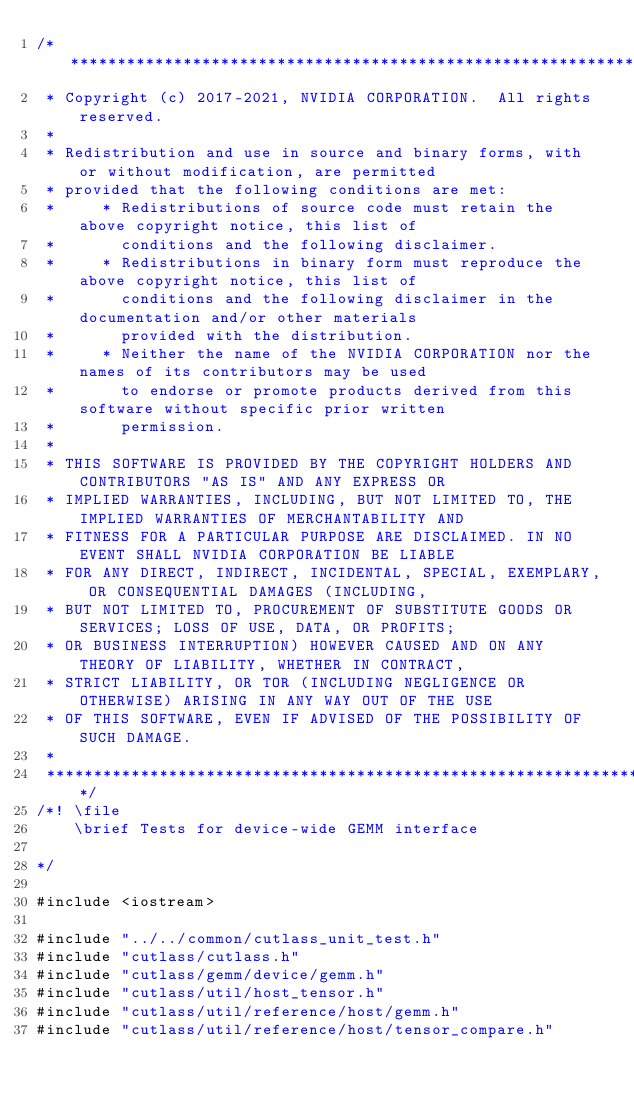Convert code to text. <code><loc_0><loc_0><loc_500><loc_500><_Cuda_>/***************************************************************************************************
 * Copyright (c) 2017-2021, NVIDIA CORPORATION.  All rights reserved.
 *
 * Redistribution and use in source and binary forms, with or without modification, are permitted
 * provided that the following conditions are met:
 *     * Redistributions of source code must retain the above copyright notice, this list of
 *       conditions and the following disclaimer.
 *     * Redistributions in binary form must reproduce the above copyright notice, this list of
 *       conditions and the following disclaimer in the documentation and/or other materials
 *       provided with the distribution.
 *     * Neither the name of the NVIDIA CORPORATION nor the names of its contributors may be used
 *       to endorse or promote products derived from this software without specific prior written
 *       permission.
 *
 * THIS SOFTWARE IS PROVIDED BY THE COPYRIGHT HOLDERS AND CONTRIBUTORS "AS IS" AND ANY EXPRESS OR
 * IMPLIED WARRANTIES, INCLUDING, BUT NOT LIMITED TO, THE IMPLIED WARRANTIES OF MERCHANTABILITY AND
 * FITNESS FOR A PARTICULAR PURPOSE ARE DISCLAIMED. IN NO EVENT SHALL NVIDIA CORPORATION BE LIABLE
 * FOR ANY DIRECT, INDIRECT, INCIDENTAL, SPECIAL, EXEMPLARY, OR CONSEQUENTIAL DAMAGES (INCLUDING,
 * BUT NOT LIMITED TO, PROCUREMENT OF SUBSTITUTE GOODS OR SERVICES; LOSS OF USE, DATA, OR PROFITS;
 * OR BUSINESS INTERRUPTION) HOWEVER CAUSED AND ON ANY THEORY OF LIABILITY, WHETHER IN CONTRACT,
 * STRICT LIABILITY, OR TOR (INCLUDING NEGLIGENCE OR OTHERWISE) ARISING IN ANY WAY OUT OF THE USE
 * OF THIS SOFTWARE, EVEN IF ADVISED OF THE POSSIBILITY OF SUCH DAMAGE.
 *
 **************************************************************************************************/
/*! \file
    \brief Tests for device-wide GEMM interface
    
*/

#include <iostream>

#include "../../common/cutlass_unit_test.h"
#include "cutlass/cutlass.h"
#include "cutlass/gemm/device/gemm.h"
#include "cutlass/util/host_tensor.h"
#include "cutlass/util/reference/host/gemm.h"
#include "cutlass/util/reference/host/tensor_compare.h"</code> 